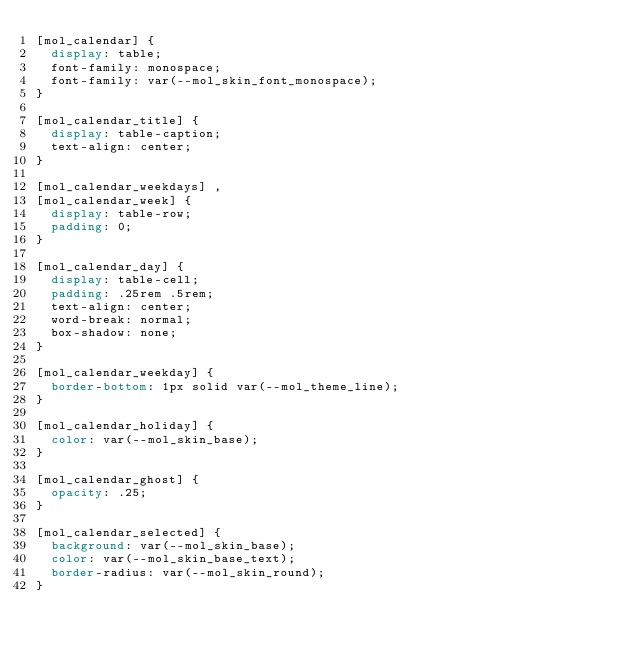<code> <loc_0><loc_0><loc_500><loc_500><_CSS_>[mol_calendar] {
	display: table;
	font-family: monospace;
	font-family: var(--mol_skin_font_monospace);
}

[mol_calendar_title] {
	display: table-caption;
	text-align: center;
}

[mol_calendar_weekdays] ,
[mol_calendar_week] {
	display: table-row;
	padding: 0;
}

[mol_calendar_day] {
	display: table-cell;
	padding: .25rem .5rem;
	text-align: center;
	word-break: normal;
	box-shadow: none;
}

[mol_calendar_weekday] {
	border-bottom: 1px solid var(--mol_theme_line);
}

[mol_calendar_holiday] {
	color: var(--mol_skin_base);
}

[mol_calendar_ghost] {
	opacity: .25;
}

[mol_calendar_selected] {
	background: var(--mol_skin_base);
	color: var(--mol_skin_base_text);
	border-radius: var(--mol_skin_round);
}
</code> 